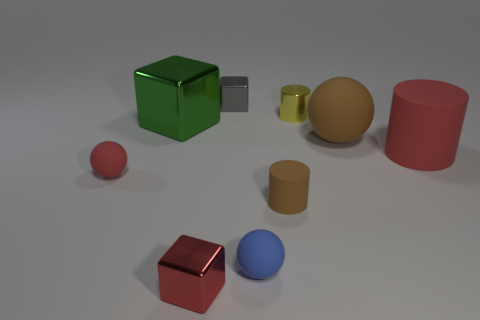The big thing that is made of the same material as the red cylinder is what shape?
Offer a terse response. Sphere. How many green objects are either large matte cylinders or small rubber cylinders?
Your answer should be compact. 0. There is a red shiny object; are there any red spheres right of it?
Provide a succinct answer. No. There is a red matte thing in front of the large red cylinder; is it the same shape as the brown rubber thing to the left of the brown rubber sphere?
Your answer should be compact. No. There is a red thing that is the same shape as the tiny blue matte thing; what material is it?
Provide a succinct answer. Rubber. What number of balls are either large rubber things or shiny things?
Offer a terse response. 1. How many big blocks are made of the same material as the small blue ball?
Ensure brevity in your answer.  0. Are the small object that is in front of the blue matte thing and the red thing that is right of the yellow metallic thing made of the same material?
Offer a very short reply. No. How many red blocks are in front of the tiny shiny object in front of the cylinder behind the big brown rubber object?
Keep it short and to the point. 0. There is a tiny cube that is in front of the tiny red matte sphere; is it the same color as the small cylinder that is behind the red rubber ball?
Provide a short and direct response. No. 